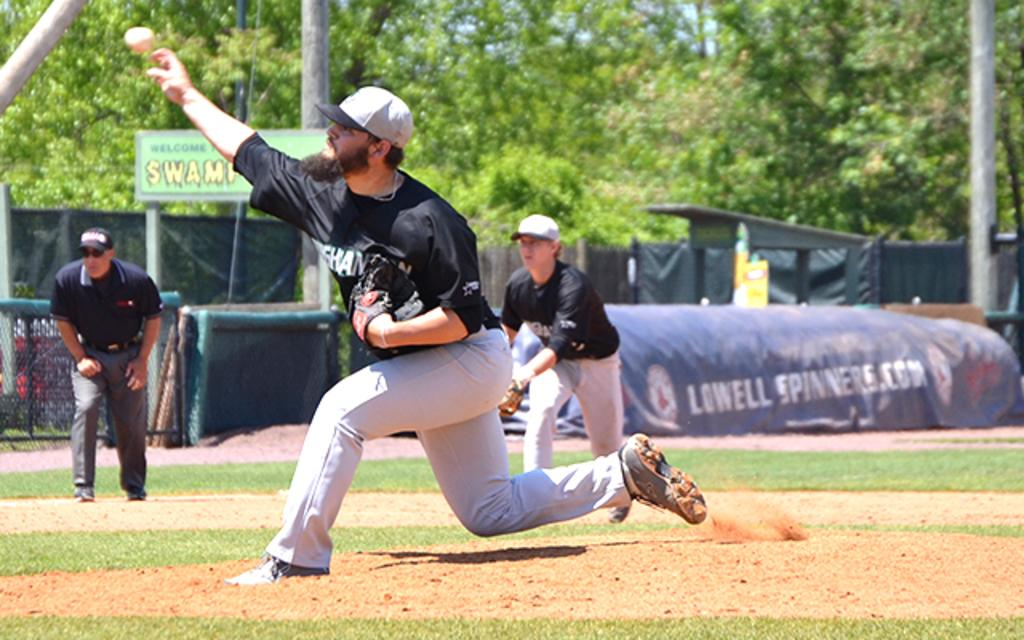<image>
Write a terse but informative summary of the picture. the word Lowell is on the large item next to the field 